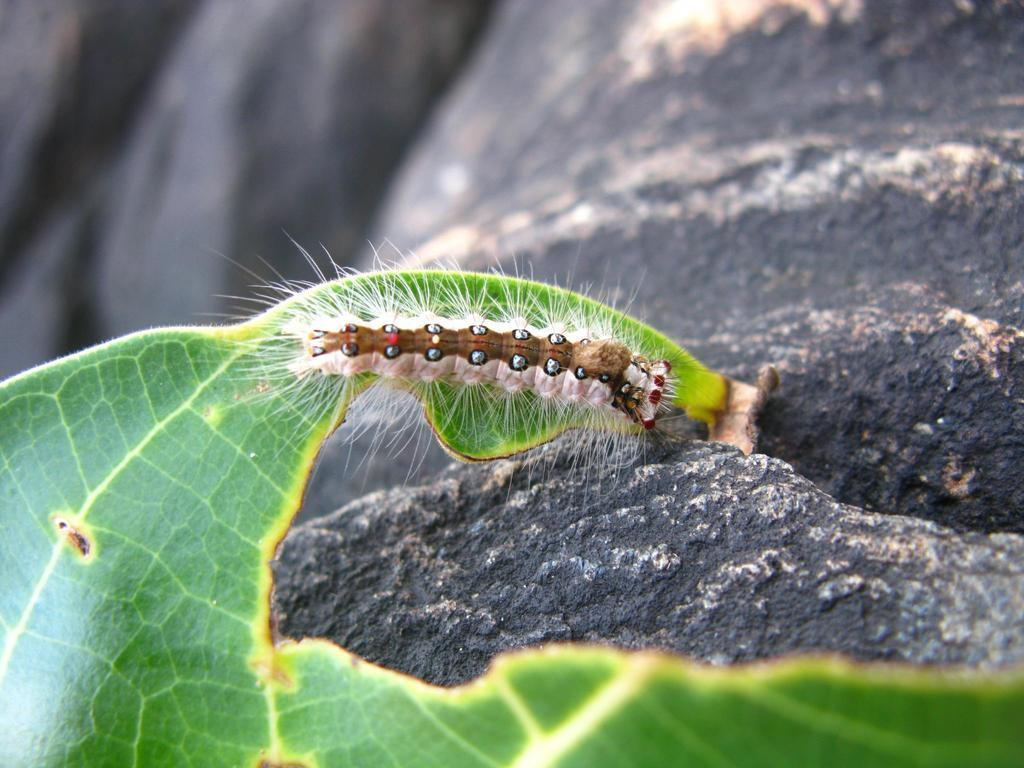What type of creature is present in the image? There is a caterpillar in the image. What is the caterpillar sitting on or near in the image? There is a leaf in the image. What can be seen in the background of the image? There is a rock in the background of the image. What type of match is being used by the caterpillar in the image? There is no match present in the image; it features a caterpillar and a leaf. How many bushes are visible in the image? There are no bushes visible in the image; it only shows a caterpillar, a leaf, and a rock in the background. 